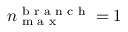Convert formula to latex. <formula><loc_0><loc_0><loc_500><loc_500>n _ { \max } ^ { b r a n c h } = 1</formula> 